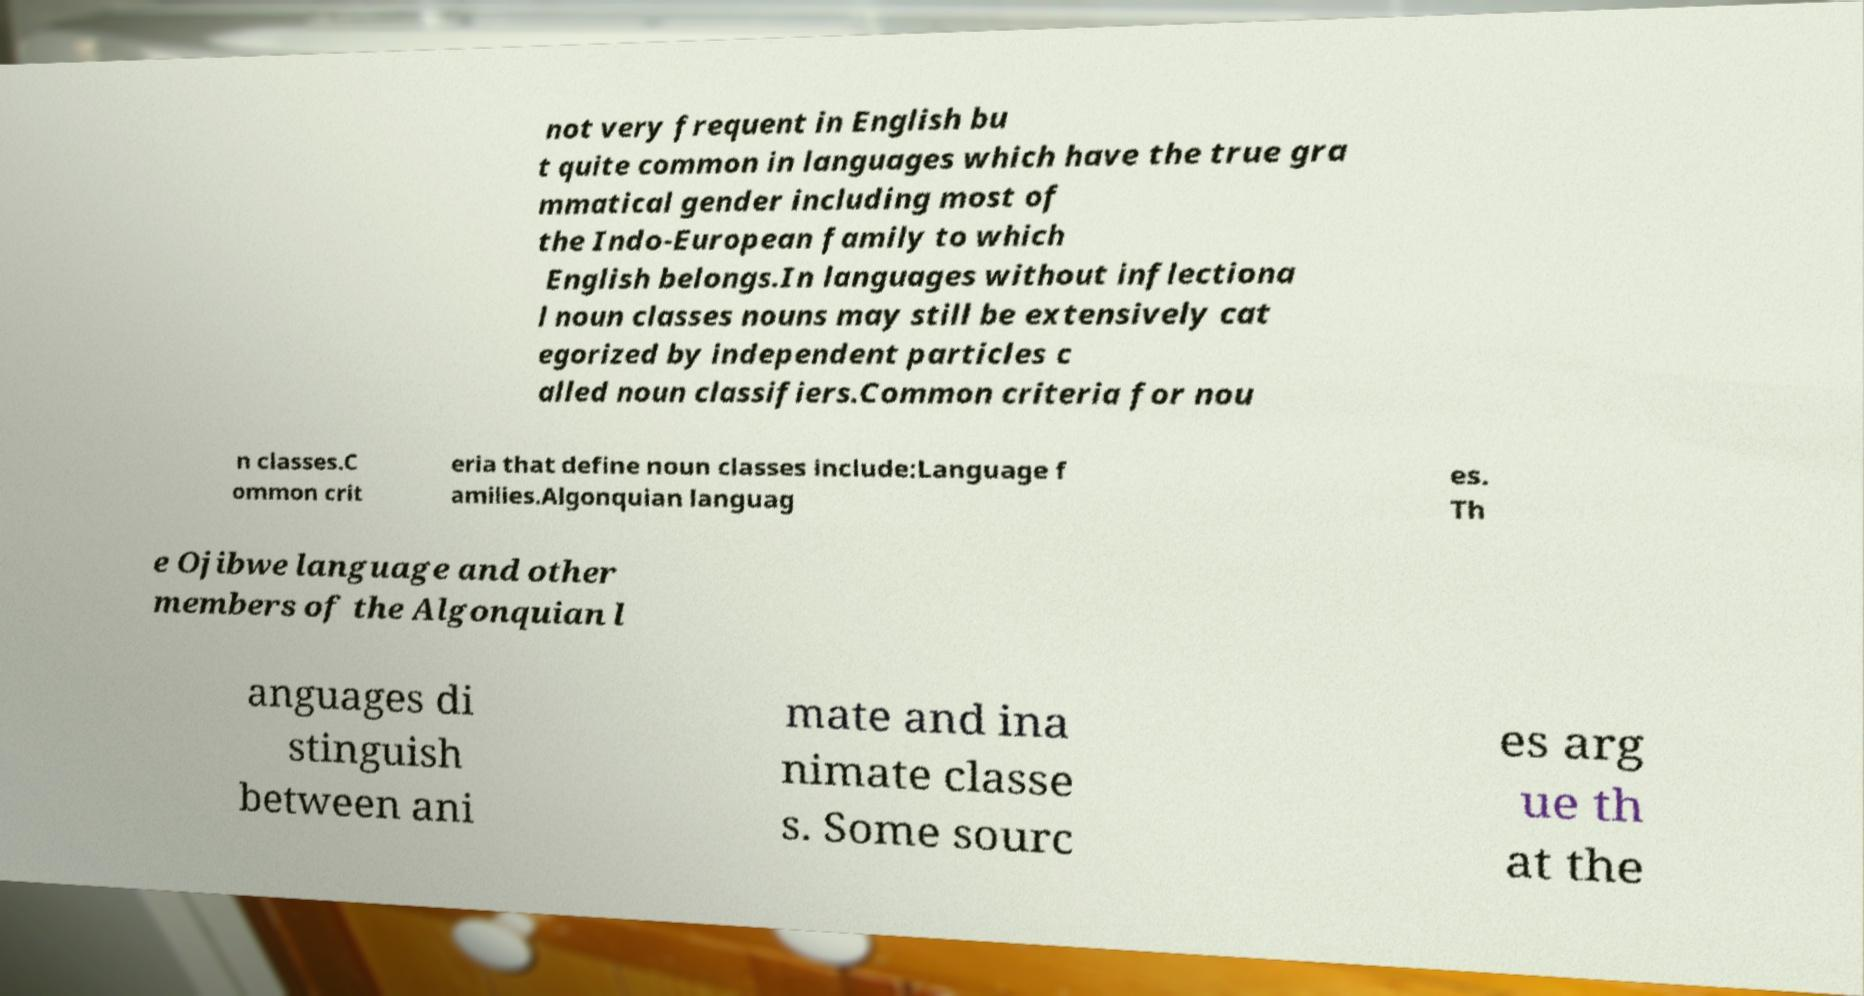Can you accurately transcribe the text from the provided image for me? not very frequent in English bu t quite common in languages which have the true gra mmatical gender including most of the Indo-European family to which English belongs.In languages without inflectiona l noun classes nouns may still be extensively cat egorized by independent particles c alled noun classifiers.Common criteria for nou n classes.C ommon crit eria that define noun classes include:Language f amilies.Algonquian languag es. Th e Ojibwe language and other members of the Algonquian l anguages di stinguish between ani mate and ina nimate classe s. Some sourc es arg ue th at the 